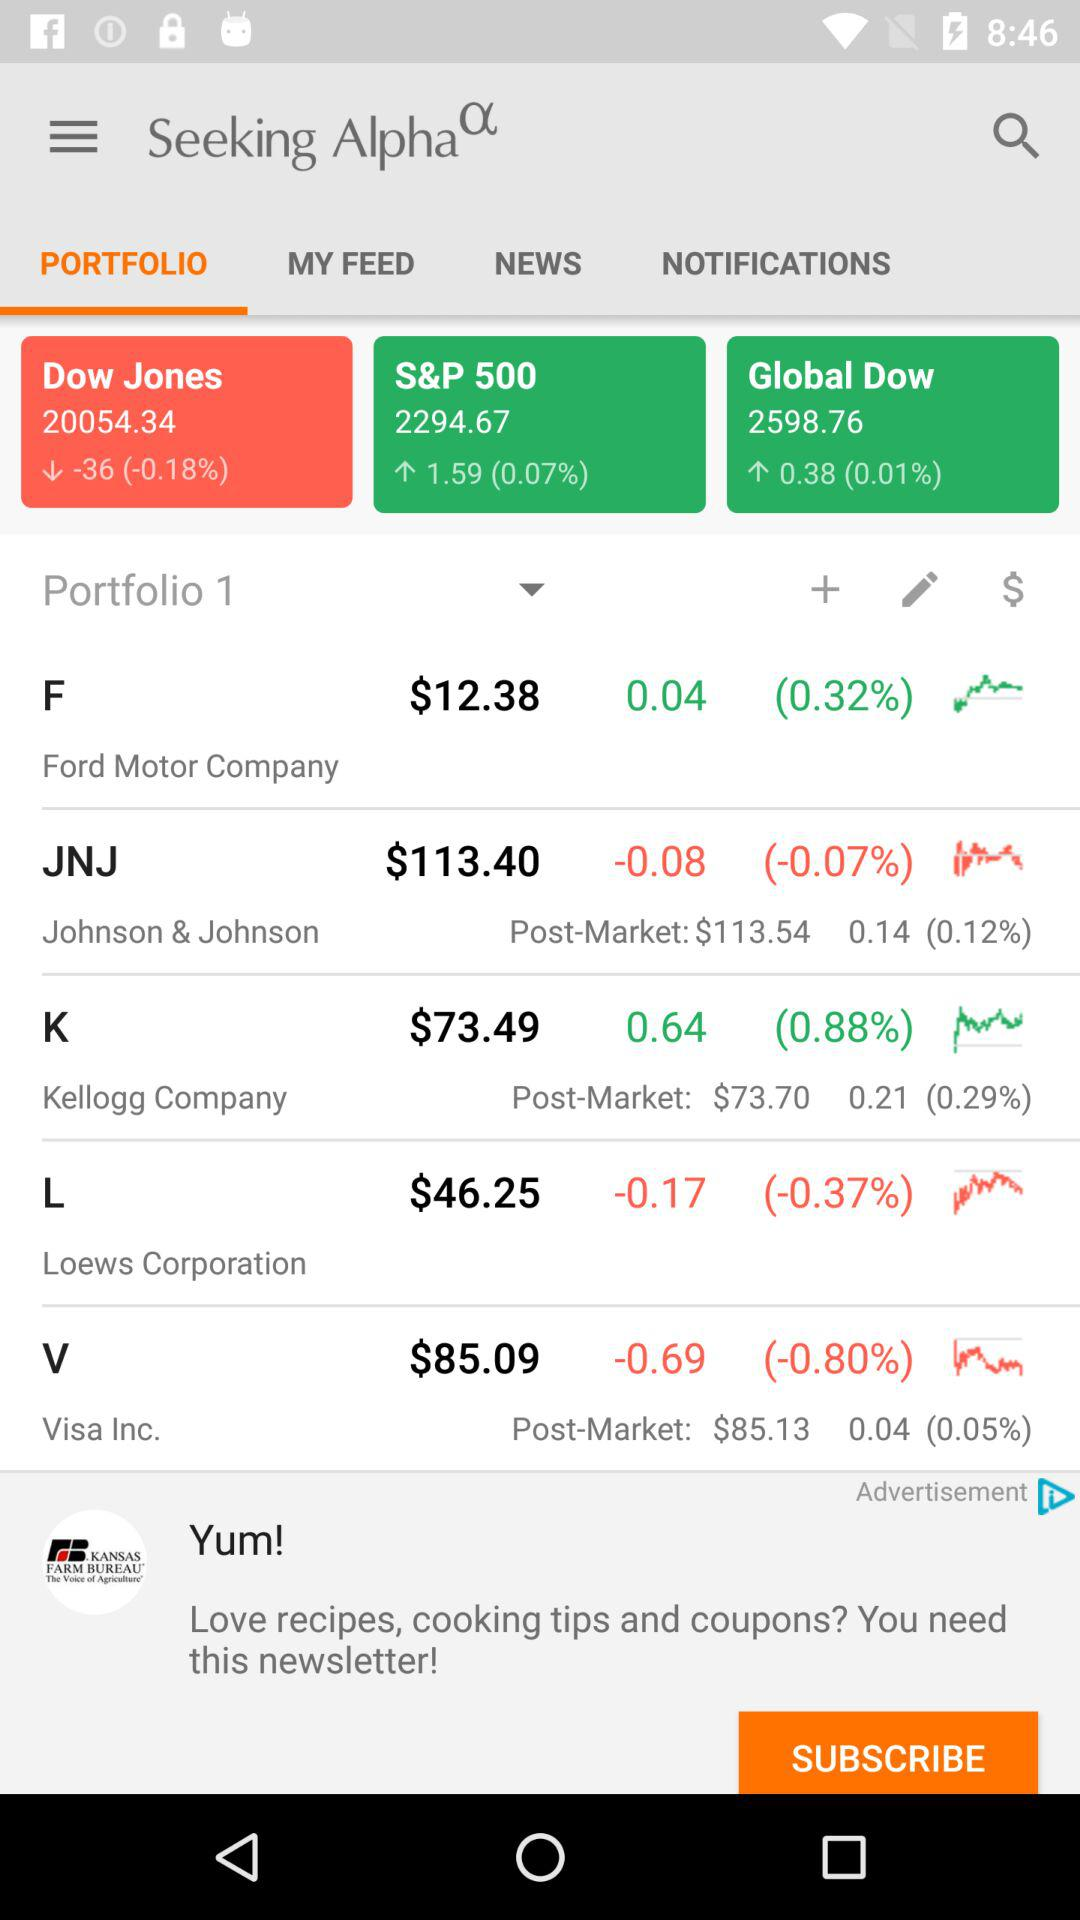How much is the change in percent for the Visa Inc. stock?
Answer the question using a single word or phrase. -0.80% 